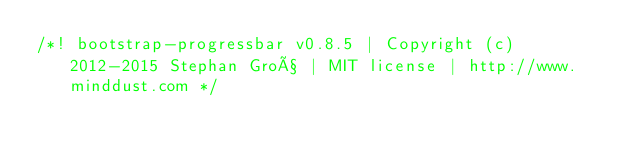Convert code to text. <code><loc_0><loc_0><loc_500><loc_500><_CSS_>/*! bootstrap-progressbar v0.8.5 | Copyright (c) 2012-2015 Stephan Groß | MIT license | http://www.minddust.com */</code> 